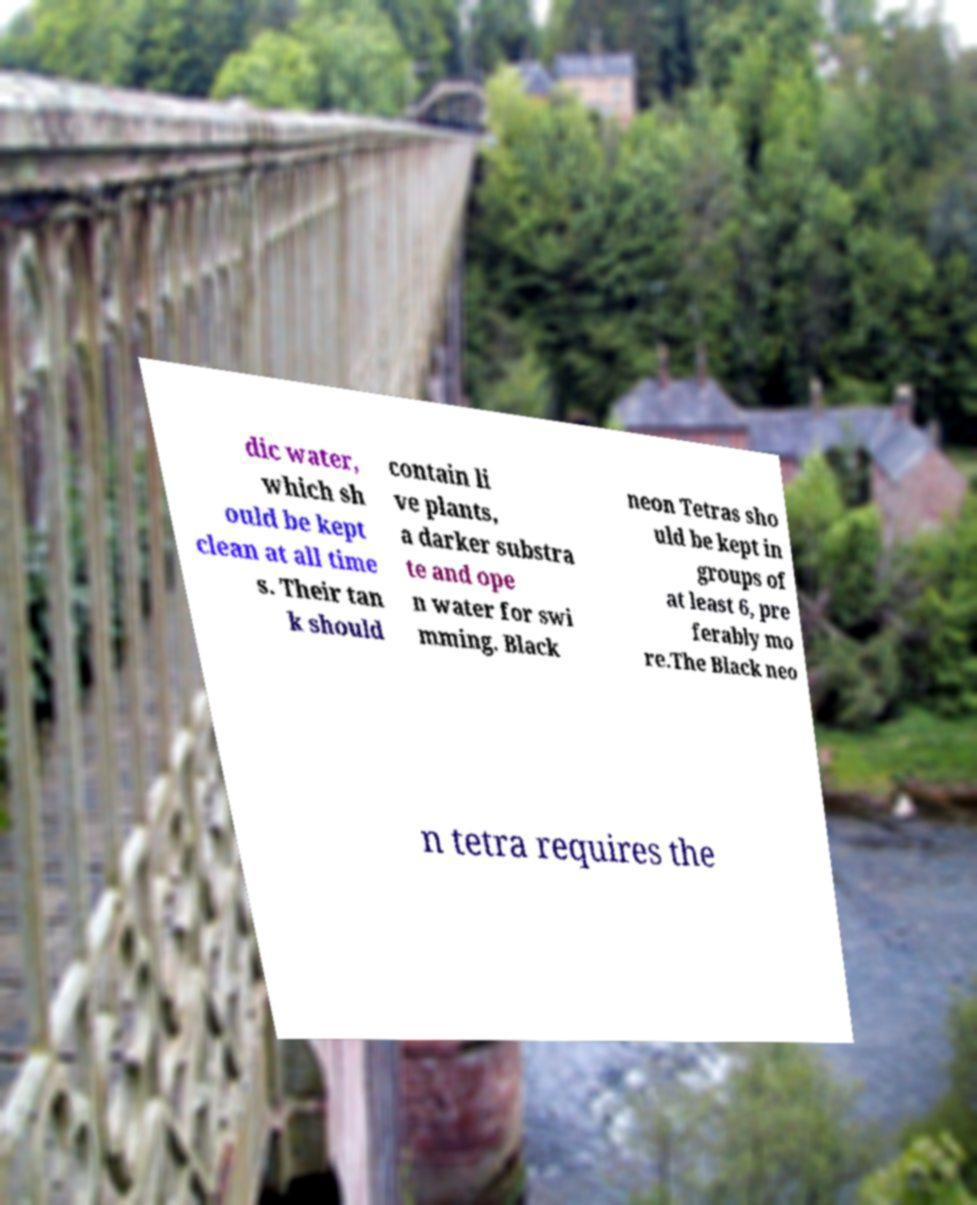There's text embedded in this image that I need extracted. Can you transcribe it verbatim? dic water, which sh ould be kept clean at all time s. Their tan k should contain li ve plants, a darker substra te and ope n water for swi mming. Black neon Tetras sho uld be kept in groups of at least 6, pre ferably mo re.The Black neo n tetra requires the 